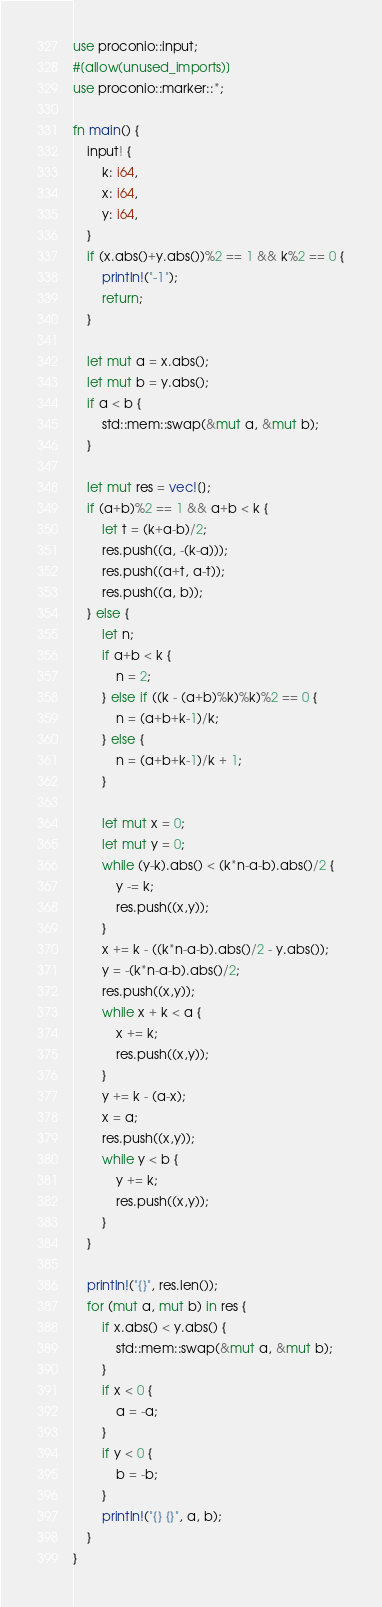Convert code to text. <code><loc_0><loc_0><loc_500><loc_500><_Rust_>use proconio::input;
#[allow(unused_imports)]
use proconio::marker::*;

fn main() {
    input! {
        k: i64,
        x: i64,
        y: i64,
    }
    if (x.abs()+y.abs())%2 == 1 && k%2 == 0 {
        println!("-1");
        return;
    }

    let mut a = x.abs();
    let mut b = y.abs();
    if a < b {
        std::mem::swap(&mut a, &mut b);
    }

    let mut res = vec![];
    if (a+b)%2 == 1 && a+b < k {
        let t = (k+a-b)/2;
        res.push((a, -(k-a)));
        res.push((a+t, a-t));
        res.push((a, b));
    } else {
        let n;
        if a+b < k {
            n = 2;
        } else if ((k - (a+b)%k)%k)%2 == 0 {
            n = (a+b+k-1)/k;
        } else {
            n = (a+b+k-1)/k + 1;
        }

        let mut x = 0;
        let mut y = 0;
        while (y-k).abs() < (k*n-a-b).abs()/2 {
            y -= k;
            res.push((x,y));
        }
        x += k - ((k*n-a-b).abs()/2 - y.abs());
        y = -(k*n-a-b).abs()/2;
        res.push((x,y));
        while x + k < a {
            x += k;
            res.push((x,y));
        }
        y += k - (a-x);
        x = a;
        res.push((x,y));
        while y < b {
            y += k;
            res.push((x,y));
        }
    }

    println!("{}", res.len());
    for (mut a, mut b) in res {
        if x.abs() < y.abs() {
            std::mem::swap(&mut a, &mut b);
        }
        if x < 0 {
            a = -a;
        }
        if y < 0 {
            b = -b;
        }
        println!("{} {}", a, b);
    }
}
</code> 